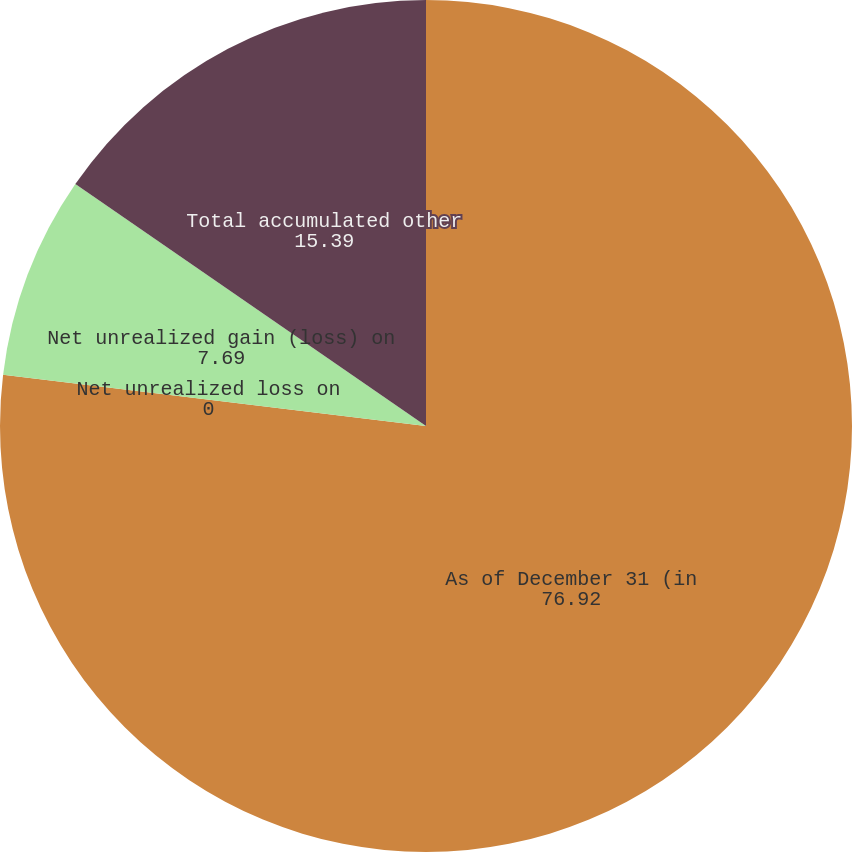Convert chart. <chart><loc_0><loc_0><loc_500><loc_500><pie_chart><fcel>As of December 31 (in<fcel>Net unrealized loss on<fcel>Net unrealized gain (loss) on<fcel>Total accumulated other<nl><fcel>76.92%<fcel>0.0%<fcel>7.69%<fcel>15.39%<nl></chart> 